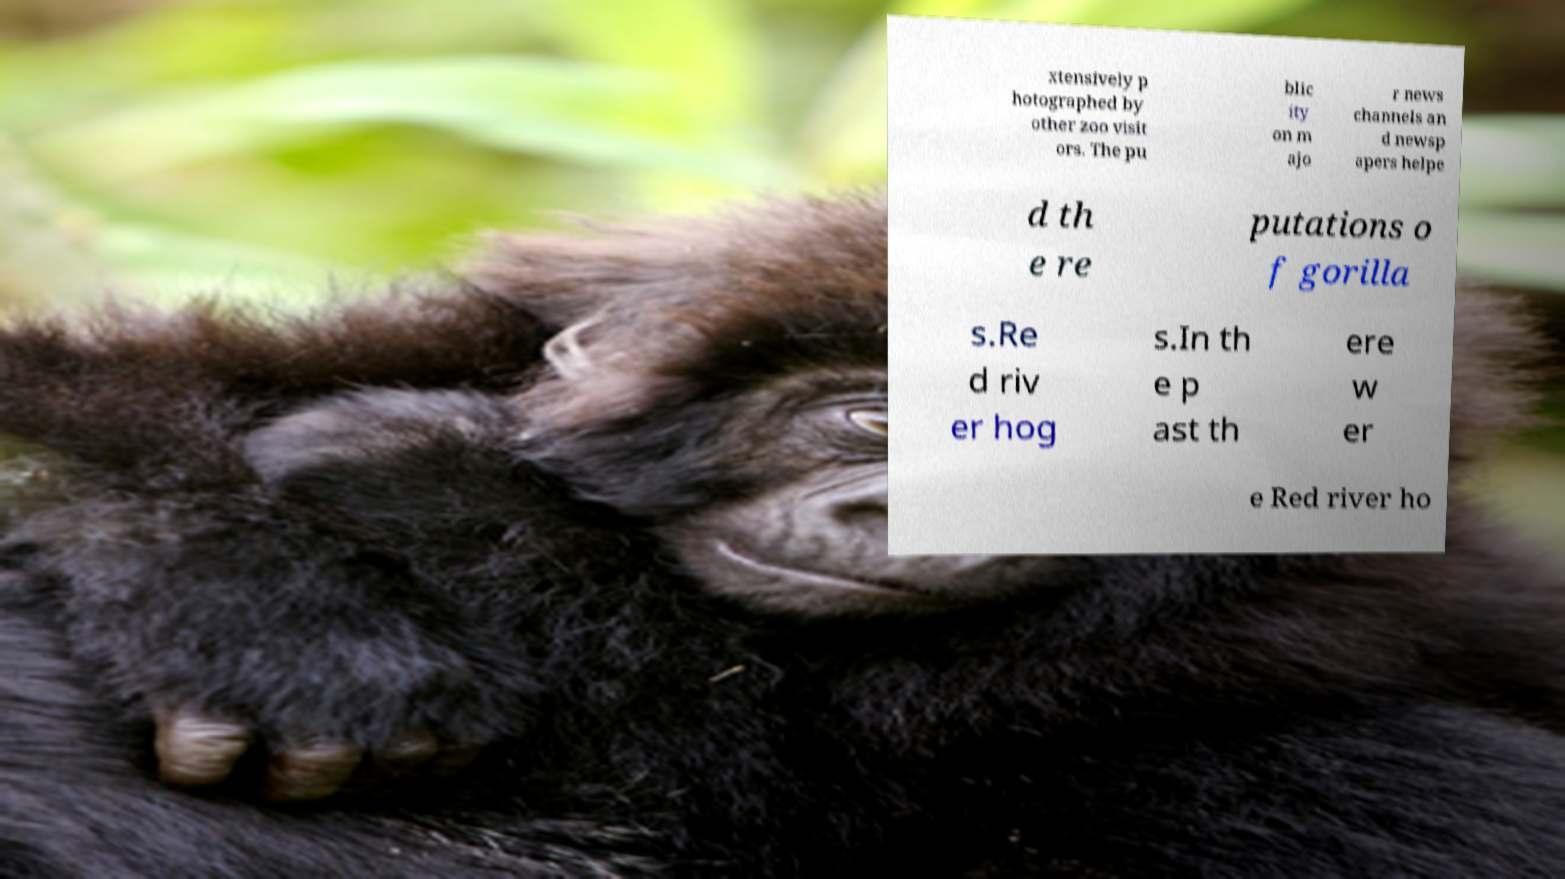Please identify and transcribe the text found in this image. xtensively p hotographed by other zoo visit ors. The pu blic ity on m ajo r news channels an d newsp apers helpe d th e re putations o f gorilla s.Re d riv er hog s.In th e p ast th ere w er e Red river ho 